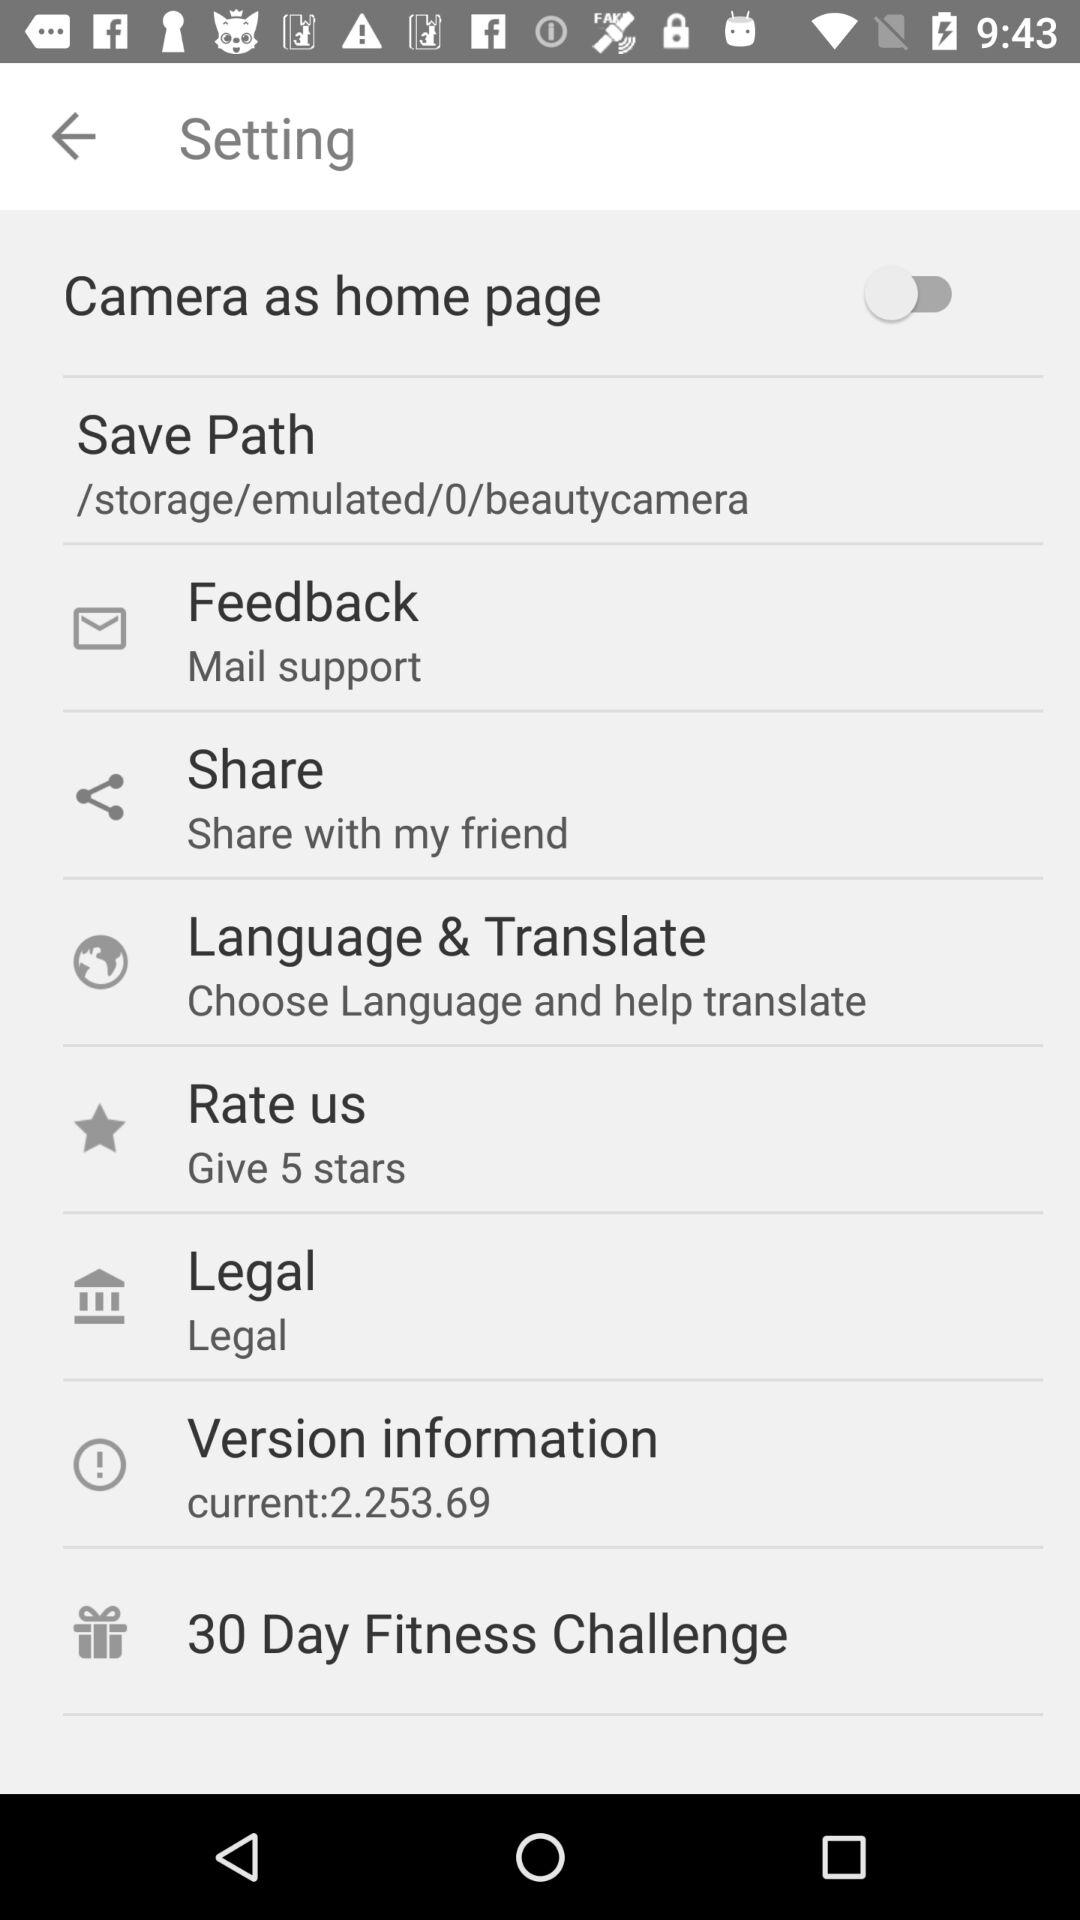What is the status of "Camera as home page"? The status is "off". 